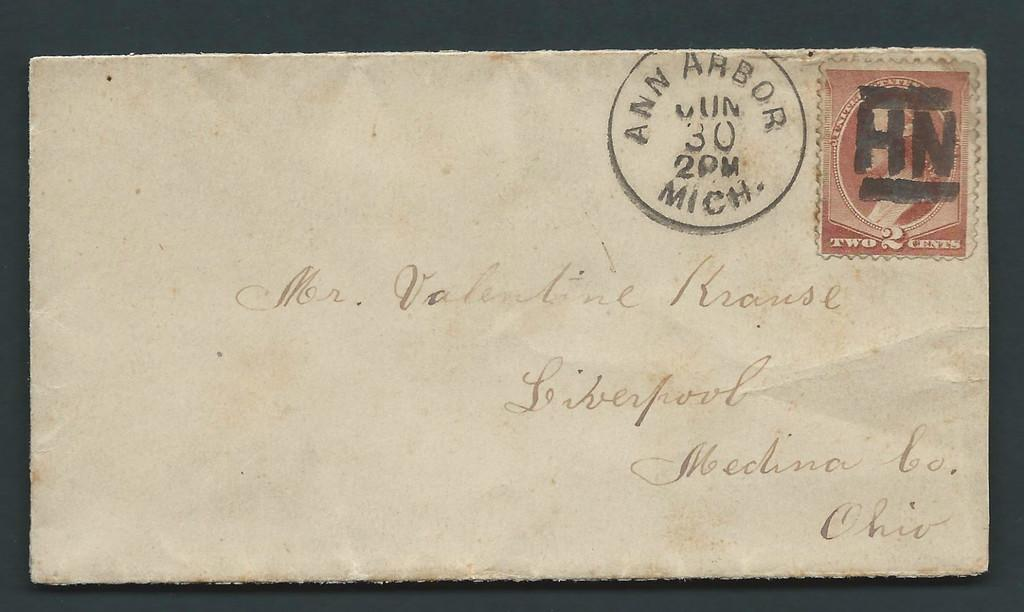<image>
Describe the image concisely. A letter addressed to Krause living in Ohio. 